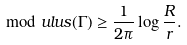Convert formula to latex. <formula><loc_0><loc_0><loc_500><loc_500>\mod u l u s ( \Gamma ) \geq \frac { 1 } { 2 \pi } \log \frac { R } { r } .</formula> 